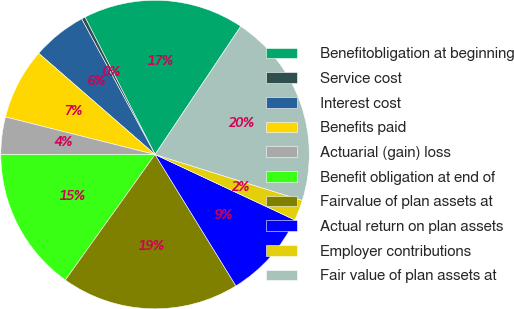Convert chart. <chart><loc_0><loc_0><loc_500><loc_500><pie_chart><fcel>Benefitobligation at beginning<fcel>Service cost<fcel>Interest cost<fcel>Benefits paid<fcel>Actuarial (gain) loss<fcel>Benefit obligation at end of<fcel>Fairvalue of plan assets at<fcel>Actual return on plan assets<fcel>Employer contributions<fcel>Fair value of plan assets at<nl><fcel>16.88%<fcel>0.39%<fcel>5.71%<fcel>7.48%<fcel>3.93%<fcel>15.11%<fcel>18.66%<fcel>9.25%<fcel>2.16%<fcel>20.43%<nl></chart> 